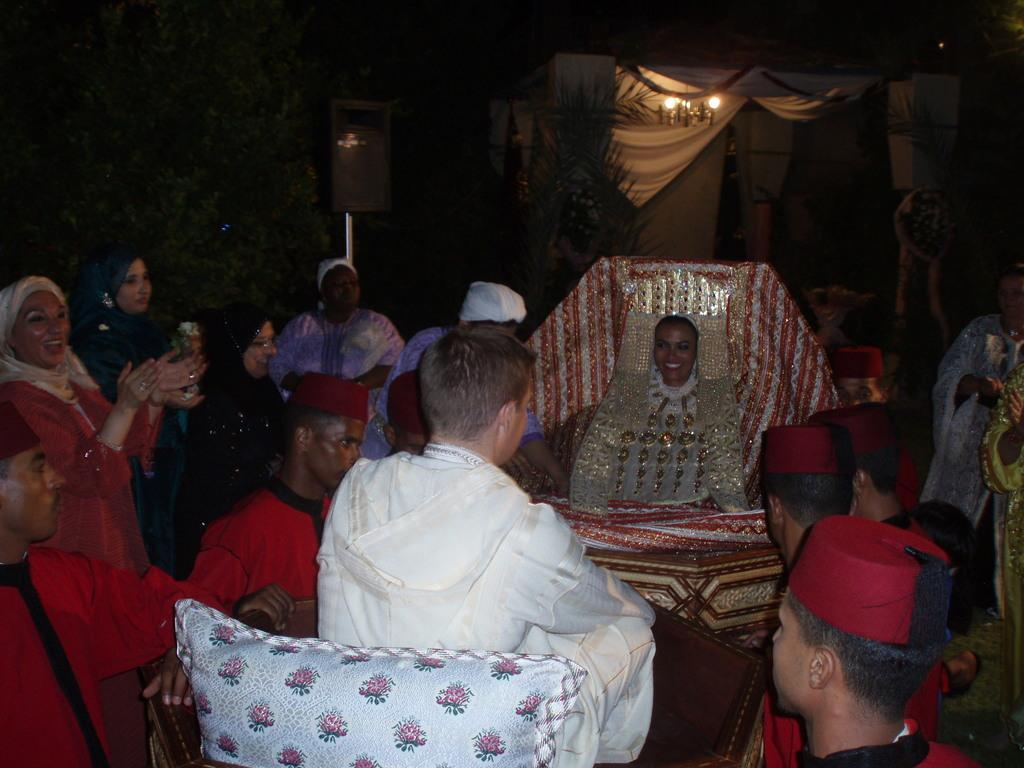What are the people in the image doing? The persons in the image are standing and sitting, and they are smiling. What can be seen in the background of the image? There are plants, a white curtain, and a light hanging in the background of the image. What type of shock can be seen affecting the persons in the image? There is no shock present in the image; the persons are smiling and appear to be enjoying themselves. What type of crook is visible in the image? There is no crook present in the image; it features persons standing and sitting, plants, a white curtain, and a light hanging in the background. 